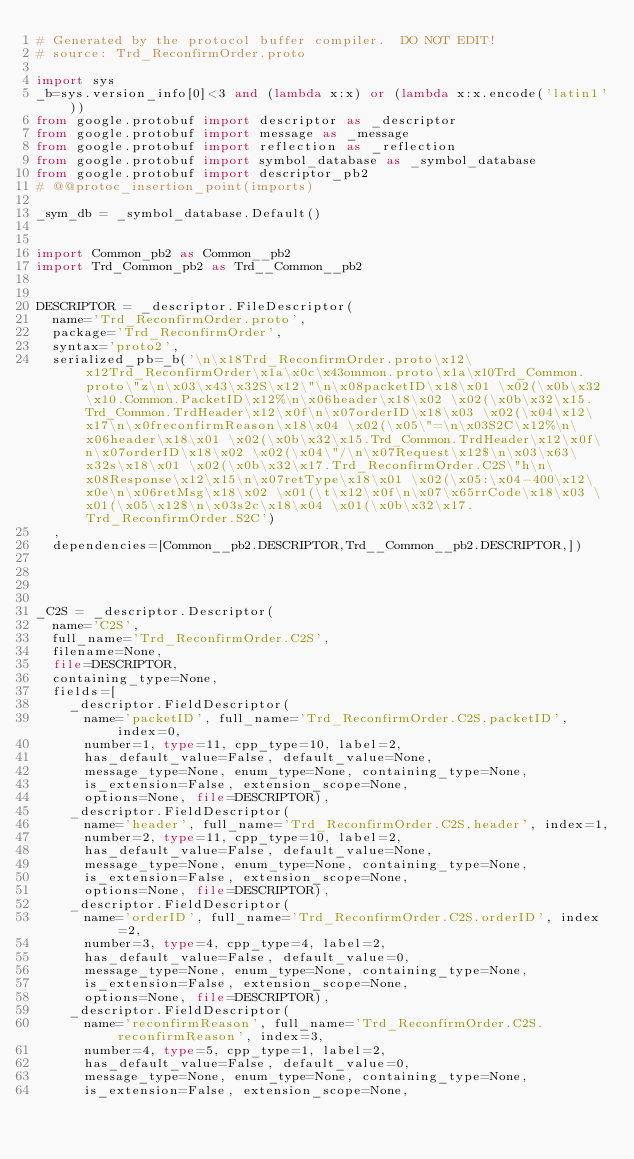Convert code to text. <code><loc_0><loc_0><loc_500><loc_500><_Python_># Generated by the protocol buffer compiler.  DO NOT EDIT!
# source: Trd_ReconfirmOrder.proto

import sys
_b=sys.version_info[0]<3 and (lambda x:x) or (lambda x:x.encode('latin1'))
from google.protobuf import descriptor as _descriptor
from google.protobuf import message as _message
from google.protobuf import reflection as _reflection
from google.protobuf import symbol_database as _symbol_database
from google.protobuf import descriptor_pb2
# @@protoc_insertion_point(imports)

_sym_db = _symbol_database.Default()


import Common_pb2 as Common__pb2
import Trd_Common_pb2 as Trd__Common__pb2


DESCRIPTOR = _descriptor.FileDescriptor(
  name='Trd_ReconfirmOrder.proto',
  package='Trd_ReconfirmOrder',
  syntax='proto2',
  serialized_pb=_b('\n\x18Trd_ReconfirmOrder.proto\x12\x12Trd_ReconfirmOrder\x1a\x0c\x43ommon.proto\x1a\x10Trd_Common.proto\"z\n\x03\x43\x32S\x12\"\n\x08packetID\x18\x01 \x02(\x0b\x32\x10.Common.PacketID\x12%\n\x06header\x18\x02 \x02(\x0b\x32\x15.Trd_Common.TrdHeader\x12\x0f\n\x07orderID\x18\x03 \x02(\x04\x12\x17\n\x0freconfirmReason\x18\x04 \x02(\x05\"=\n\x03S2C\x12%\n\x06header\x18\x01 \x02(\x0b\x32\x15.Trd_Common.TrdHeader\x12\x0f\n\x07orderID\x18\x02 \x02(\x04\"/\n\x07Request\x12$\n\x03\x63\x32s\x18\x01 \x02(\x0b\x32\x17.Trd_ReconfirmOrder.C2S\"h\n\x08Response\x12\x15\n\x07retType\x18\x01 \x02(\x05:\x04-400\x12\x0e\n\x06retMsg\x18\x02 \x01(\t\x12\x0f\n\x07\x65rrCode\x18\x03 \x01(\x05\x12$\n\x03s2c\x18\x04 \x01(\x0b\x32\x17.Trd_ReconfirmOrder.S2C')
  ,
  dependencies=[Common__pb2.DESCRIPTOR,Trd__Common__pb2.DESCRIPTOR,])




_C2S = _descriptor.Descriptor(
  name='C2S',
  full_name='Trd_ReconfirmOrder.C2S',
  filename=None,
  file=DESCRIPTOR,
  containing_type=None,
  fields=[
    _descriptor.FieldDescriptor(
      name='packetID', full_name='Trd_ReconfirmOrder.C2S.packetID', index=0,
      number=1, type=11, cpp_type=10, label=2,
      has_default_value=False, default_value=None,
      message_type=None, enum_type=None, containing_type=None,
      is_extension=False, extension_scope=None,
      options=None, file=DESCRIPTOR),
    _descriptor.FieldDescriptor(
      name='header', full_name='Trd_ReconfirmOrder.C2S.header', index=1,
      number=2, type=11, cpp_type=10, label=2,
      has_default_value=False, default_value=None,
      message_type=None, enum_type=None, containing_type=None,
      is_extension=False, extension_scope=None,
      options=None, file=DESCRIPTOR),
    _descriptor.FieldDescriptor(
      name='orderID', full_name='Trd_ReconfirmOrder.C2S.orderID', index=2,
      number=3, type=4, cpp_type=4, label=2,
      has_default_value=False, default_value=0,
      message_type=None, enum_type=None, containing_type=None,
      is_extension=False, extension_scope=None,
      options=None, file=DESCRIPTOR),
    _descriptor.FieldDescriptor(
      name='reconfirmReason', full_name='Trd_ReconfirmOrder.C2S.reconfirmReason', index=3,
      number=4, type=5, cpp_type=1, label=2,
      has_default_value=False, default_value=0,
      message_type=None, enum_type=None, containing_type=None,
      is_extension=False, extension_scope=None,</code> 